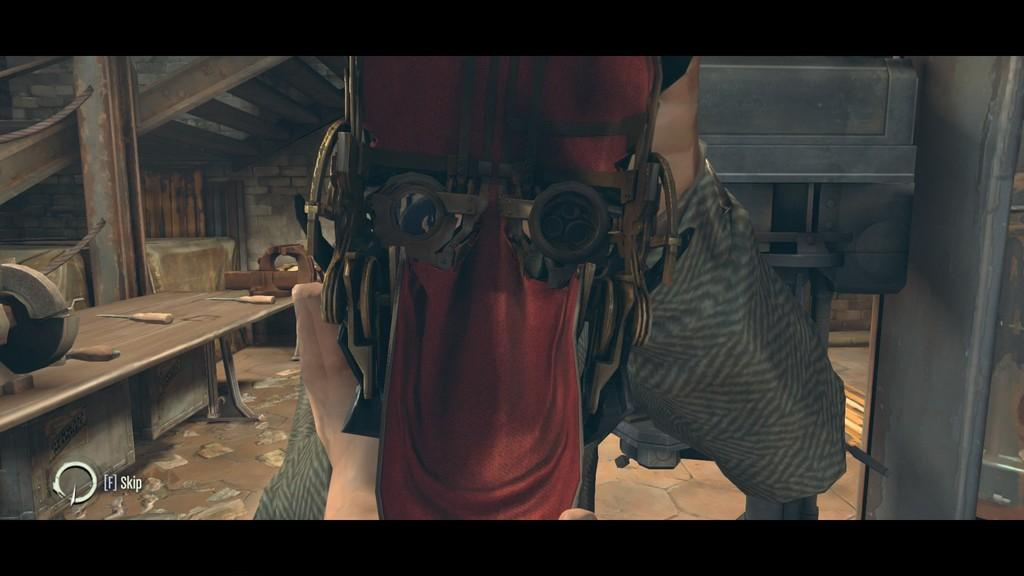What type of image is being described? The image is an animated picture. What is one of the objects visible in the image? There is a table in the image. Are there any architectural features present in the image? Yes, there are steps in the image. What can be found on the table in the image? There are tools on the table. Is there any text or logo visible in the image? Yes, there is a watermark at the bottom of the image. How many books are stacked on the steps in the image? There are no books visible in the image; it only mentions tools on the table and a watermark at the bottom. 